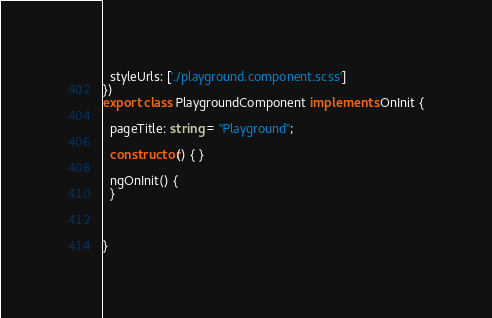Convert code to text. <code><loc_0><loc_0><loc_500><loc_500><_TypeScript_>  styleUrls: ['./playground.component.scss']
})
export class PlaygroundComponent implements OnInit {

  pageTitle: string = "Playground";
  
  constructor() { }

  ngOnInit() {
  }

  

}
</code> 